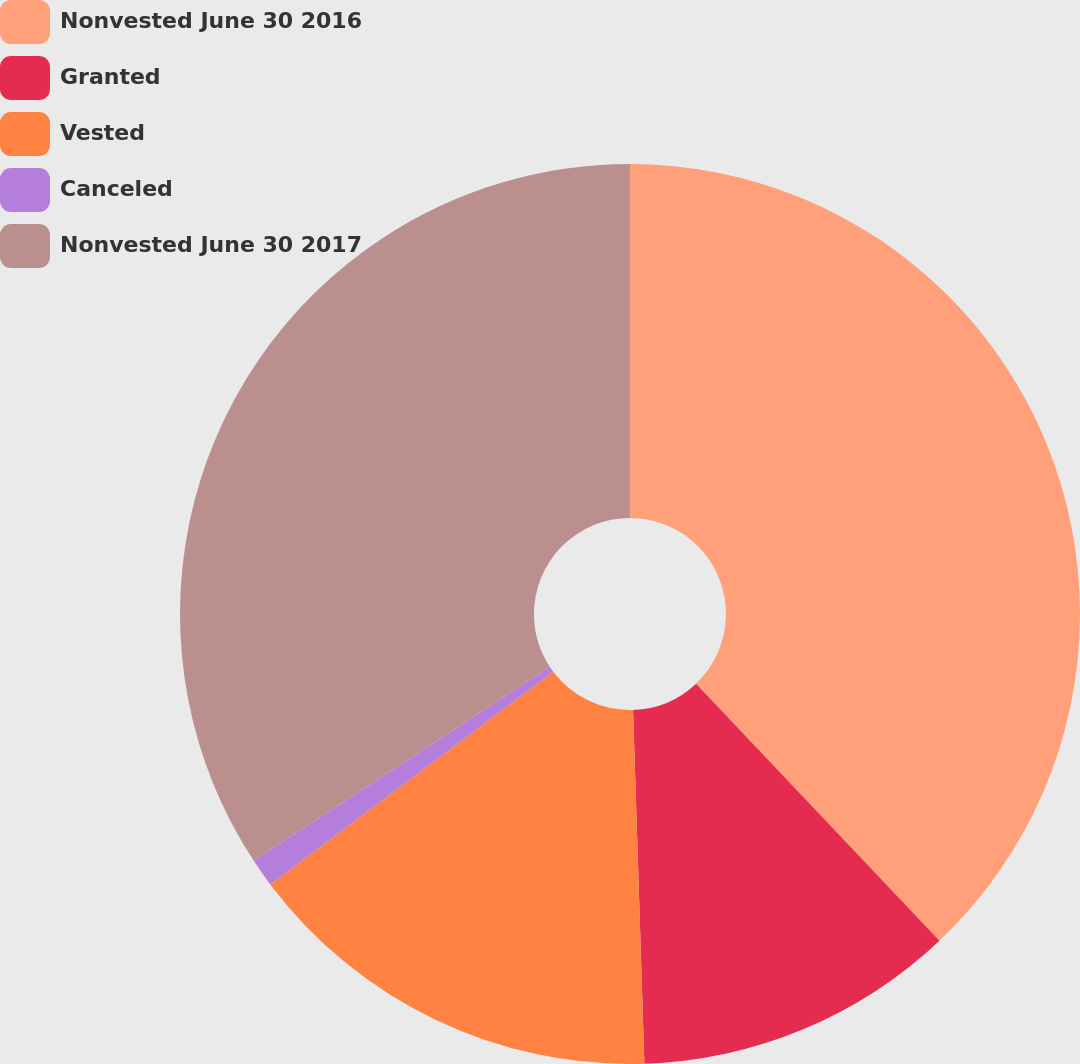Convert chart. <chart><loc_0><loc_0><loc_500><loc_500><pie_chart><fcel>Nonvested June 30 2016<fcel>Granted<fcel>Vested<fcel>Canceled<fcel>Nonvested June 30 2017<nl><fcel>37.93%<fcel>11.56%<fcel>15.25%<fcel>1.02%<fcel>34.24%<nl></chart> 